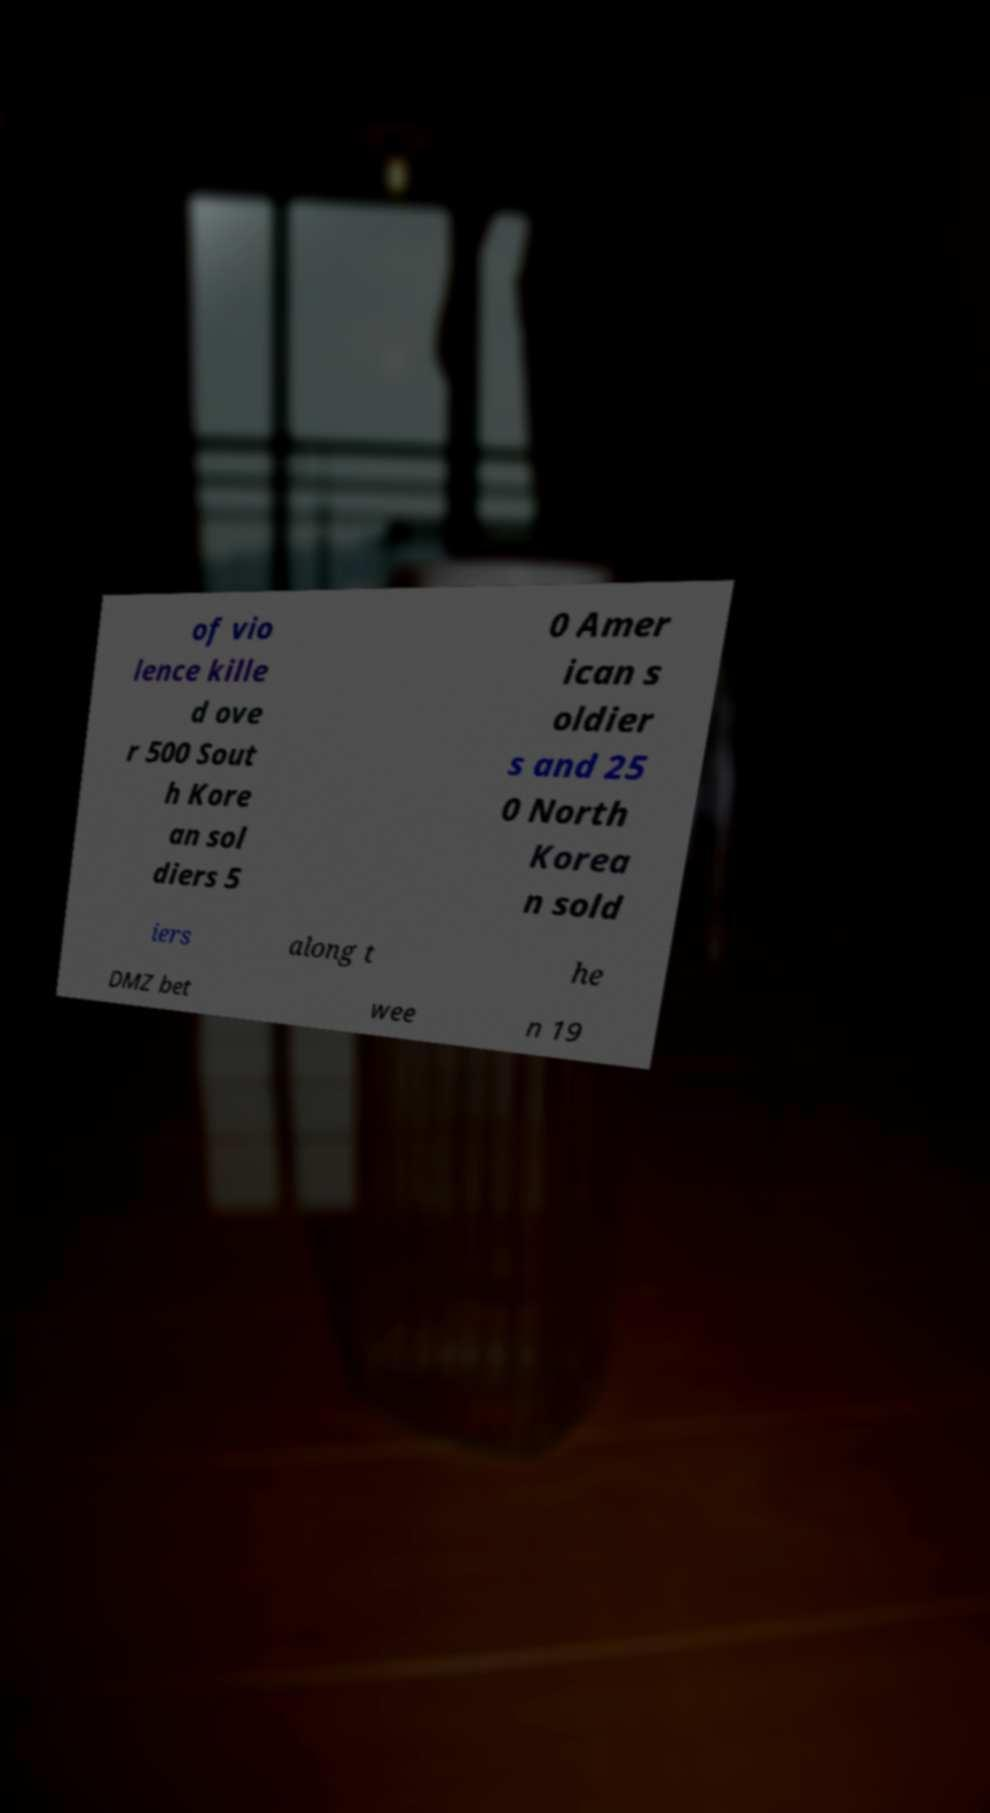What messages or text are displayed in this image? I need them in a readable, typed format. of vio lence kille d ove r 500 Sout h Kore an sol diers 5 0 Amer ican s oldier s and 25 0 North Korea n sold iers along t he DMZ bet wee n 19 